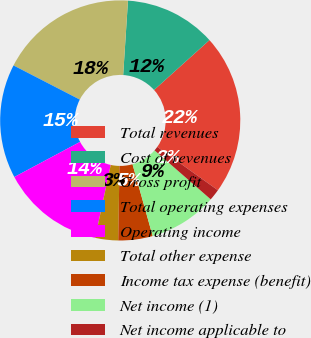Convert chart to OTSL. <chart><loc_0><loc_0><loc_500><loc_500><pie_chart><fcel>Total revenues<fcel>Cost of revenues<fcel>Gross profit<fcel>Total operating expenses<fcel>Operating income<fcel>Total other expense<fcel>Income tax expense (benefit)<fcel>Net income (1)<fcel>Net income applicable to<nl><fcel>21.54%<fcel>12.31%<fcel>18.46%<fcel>15.38%<fcel>13.85%<fcel>3.08%<fcel>4.62%<fcel>9.23%<fcel>1.54%<nl></chart> 